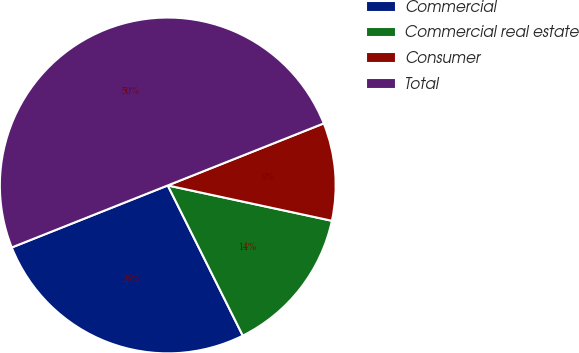Convert chart. <chart><loc_0><loc_0><loc_500><loc_500><pie_chart><fcel>Commercial<fcel>Commercial real estate<fcel>Consumer<fcel>Total<nl><fcel>26.35%<fcel>14.25%<fcel>9.4%<fcel>50.0%<nl></chart> 